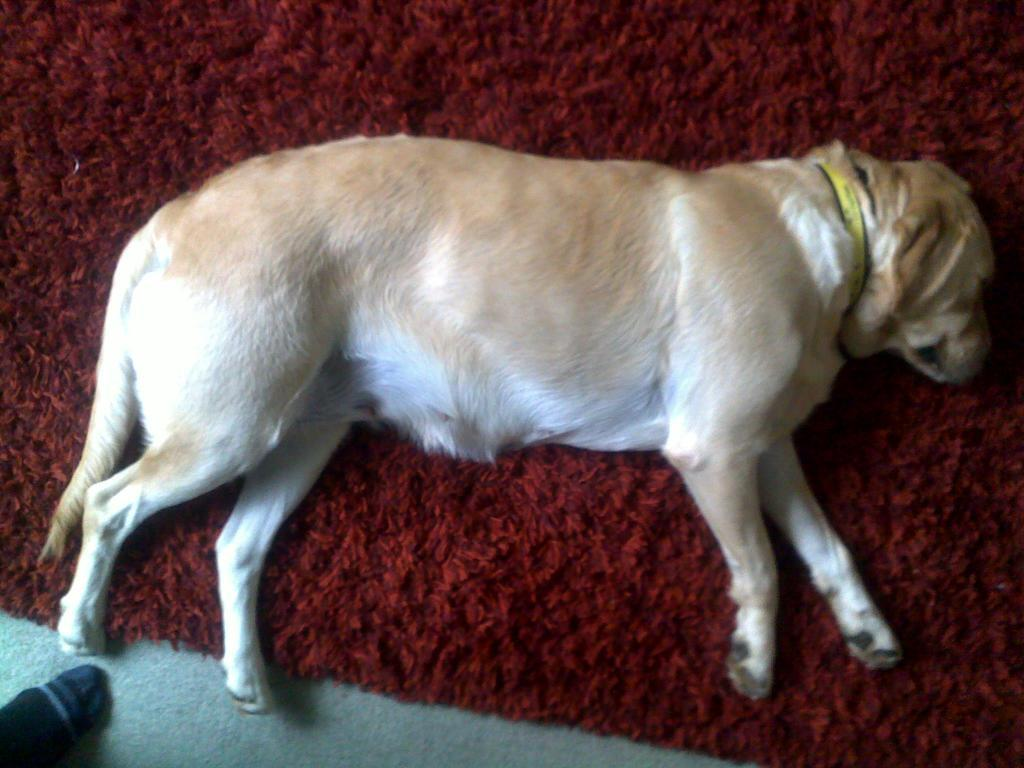What type of animal can be seen in the image? There is a dog in the image. What is the dog doing in the image? The dog is sleeping. What is the dog resting on in the image? The dog is on a red color mat. What type of education is the dog receiving in the image? There is no indication in the image that the dog is receiving any education. What type of machine can be seen in the image? There is no machine present in the image; it features a dog sleeping on a red color mat. 